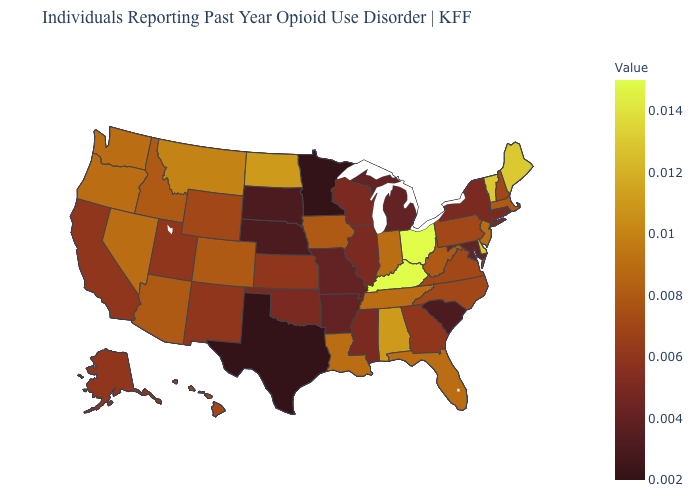Among the states that border Nebraska , which have the lowest value?
Concise answer only. South Dakota. Among the states that border Arkansas , which have the lowest value?
Short answer required. Texas. Does California have the lowest value in the West?
Quick response, please. Yes. Which states have the highest value in the USA?
Give a very brief answer. Kentucky, Ohio. Which states have the highest value in the USA?
Keep it brief. Kentucky, Ohio. 